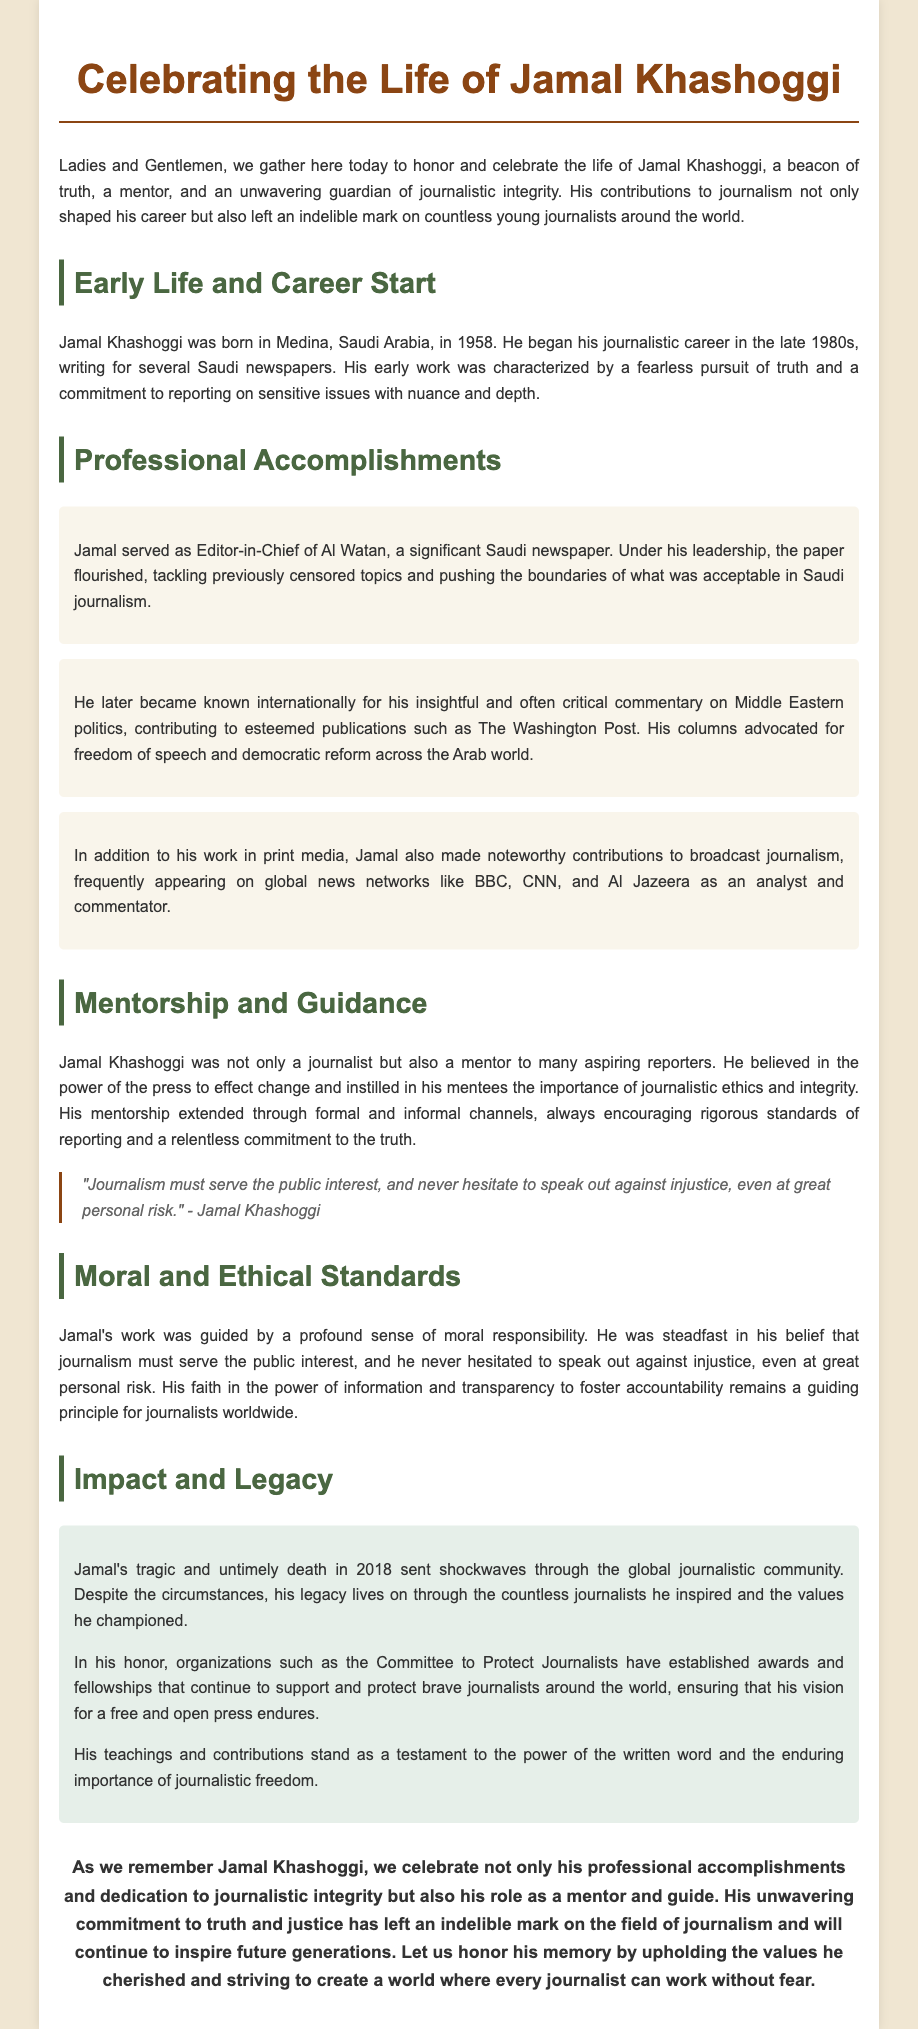What is the full name of the person being honored? The document states the full name of the person being honored is Jamal Khashoggi.
Answer: Jamal Khashoggi In which year was Jamal Khashoggi born? The document mentions that Jamal Khashoggi was born in 1958.
Answer: 1958 What title did Jamal hold at Al Watan? According to the document, Jamal served as Editor-in-Chief of Al Watan.
Answer: Editor-in-Chief What notable publication did Jamal contribute to internationally? The document specifies that he contributed to The Washington Post.
Answer: The Washington Post What is one of the moral principles emphasized by Jamal? The text highlights that journalism must serve the public interest as a moral principle emphasized by Jamal.
Answer: Serve the public interest What kind of awards were established in Jamal's honor? As mentioned in the document, awards and fellowships were established to support and protect brave journalists.
Answer: Awards and fellowships What is stated about Jamal's impact on younger journalists? The document indicates that Jamal left an indelible mark on countless young journalists around the world.
Answer: Indelible mark How did Jamal Khashoggi's death impact the journalistic community? The document states that his death sent shockwaves through the global journalistic community.
Answer: Shockwaves What key quality did Jamal instill in his mentees? It is mentioned that he instilled the importance of journalistic ethics and integrity in his mentees.
Answer: Journalistic ethics and integrity 